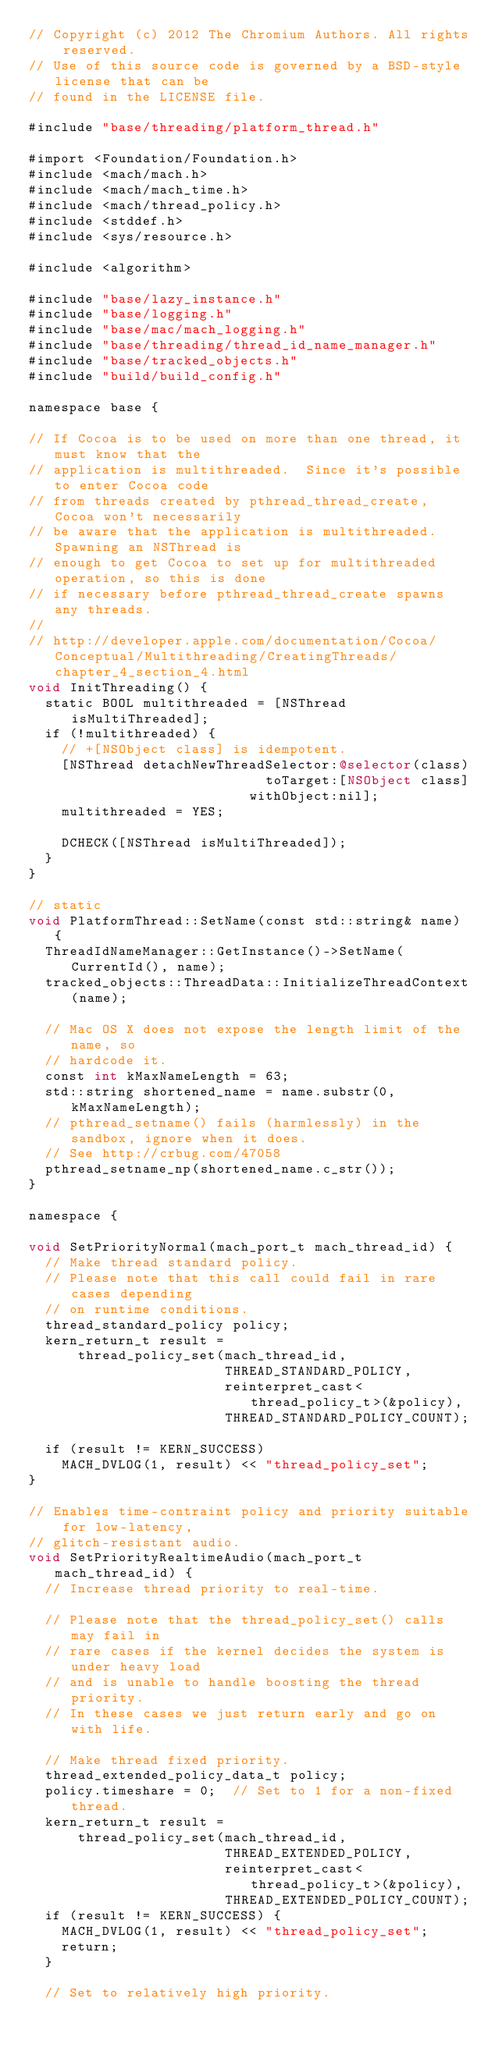<code> <loc_0><loc_0><loc_500><loc_500><_ObjectiveC_>// Copyright (c) 2012 The Chromium Authors. All rights reserved.
// Use of this source code is governed by a BSD-style license that can be
// found in the LICENSE file.

#include "base/threading/platform_thread.h"

#import <Foundation/Foundation.h>
#include <mach/mach.h>
#include <mach/mach_time.h>
#include <mach/thread_policy.h>
#include <stddef.h>
#include <sys/resource.h>

#include <algorithm>

#include "base/lazy_instance.h"
#include "base/logging.h"
#include "base/mac/mach_logging.h"
#include "base/threading/thread_id_name_manager.h"
#include "base/tracked_objects.h"
#include "build/build_config.h"

namespace base {

// If Cocoa is to be used on more than one thread, it must know that the
// application is multithreaded.  Since it's possible to enter Cocoa code
// from threads created by pthread_thread_create, Cocoa won't necessarily
// be aware that the application is multithreaded.  Spawning an NSThread is
// enough to get Cocoa to set up for multithreaded operation, so this is done
// if necessary before pthread_thread_create spawns any threads.
//
// http://developer.apple.com/documentation/Cocoa/Conceptual/Multithreading/CreatingThreads/chapter_4_section_4.html
void InitThreading() {
  static BOOL multithreaded = [NSThread isMultiThreaded];
  if (!multithreaded) {
    // +[NSObject class] is idempotent.
    [NSThread detachNewThreadSelector:@selector(class)
                             toTarget:[NSObject class]
                           withObject:nil];
    multithreaded = YES;

    DCHECK([NSThread isMultiThreaded]);
  }
}

// static
void PlatformThread::SetName(const std::string& name) {
  ThreadIdNameManager::GetInstance()->SetName(CurrentId(), name);
  tracked_objects::ThreadData::InitializeThreadContext(name);

  // Mac OS X does not expose the length limit of the name, so
  // hardcode it.
  const int kMaxNameLength = 63;
  std::string shortened_name = name.substr(0, kMaxNameLength);
  // pthread_setname() fails (harmlessly) in the sandbox, ignore when it does.
  // See http://crbug.com/47058
  pthread_setname_np(shortened_name.c_str());
}

namespace {

void SetPriorityNormal(mach_port_t mach_thread_id) {
  // Make thread standard policy.
  // Please note that this call could fail in rare cases depending
  // on runtime conditions.
  thread_standard_policy policy;
  kern_return_t result =
      thread_policy_set(mach_thread_id,
                        THREAD_STANDARD_POLICY,
                        reinterpret_cast<thread_policy_t>(&policy),
                        THREAD_STANDARD_POLICY_COUNT);

  if (result != KERN_SUCCESS)
    MACH_DVLOG(1, result) << "thread_policy_set";
}

// Enables time-contraint policy and priority suitable for low-latency,
// glitch-resistant audio.
void SetPriorityRealtimeAudio(mach_port_t mach_thread_id) {
  // Increase thread priority to real-time.

  // Please note that the thread_policy_set() calls may fail in
  // rare cases if the kernel decides the system is under heavy load
  // and is unable to handle boosting the thread priority.
  // In these cases we just return early and go on with life.

  // Make thread fixed priority.
  thread_extended_policy_data_t policy;
  policy.timeshare = 0;  // Set to 1 for a non-fixed thread.
  kern_return_t result =
      thread_policy_set(mach_thread_id,
                        THREAD_EXTENDED_POLICY,
                        reinterpret_cast<thread_policy_t>(&policy),
                        THREAD_EXTENDED_POLICY_COUNT);
  if (result != KERN_SUCCESS) {
    MACH_DVLOG(1, result) << "thread_policy_set";
    return;
  }

  // Set to relatively high priority.</code> 